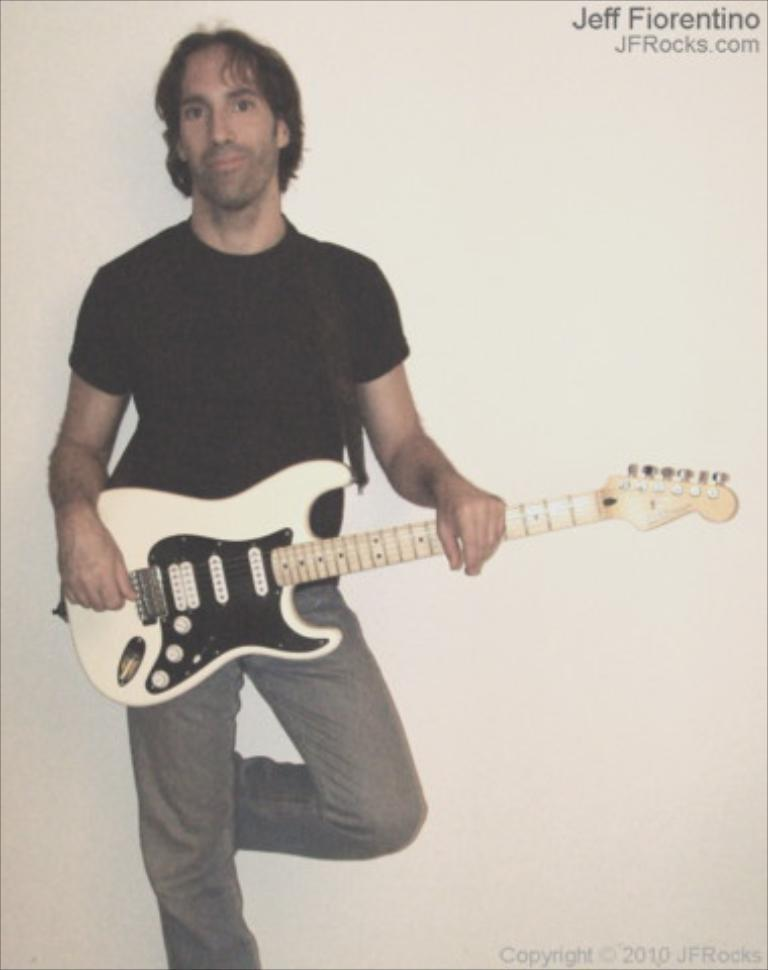What is the man in the image doing? The man is standing in the image and holding a guitar. What object is the man holding in the image? The man is holding a guitar. What can be seen in the background of the image? There is a wall in the background of the image. What type of calculator is the man using in the image? There is no calculator present in the image. What force is being applied to the guitar in the image? There is no indication of any force being applied to the guitar in the image; the man is simply holding it. 